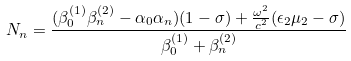<formula> <loc_0><loc_0><loc_500><loc_500>N _ { n } = \frac { ( \beta _ { 0 } ^ { ( 1 ) } \beta _ { n } ^ { ( 2 ) } - \alpha _ { 0 } \alpha _ { n } ) ( 1 - \sigma ) + \frac { \omega ^ { 2 } } { c ^ { 2 } } ( \epsilon _ { 2 } \mu _ { 2 } - \sigma ) } { \beta _ { 0 } ^ { ( 1 ) } + \beta _ { n } ^ { ( 2 ) } } \,</formula> 